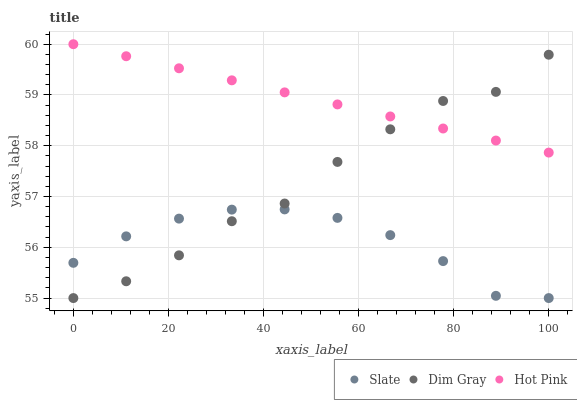Does Slate have the minimum area under the curve?
Answer yes or no. Yes. Does Hot Pink have the maximum area under the curve?
Answer yes or no. Yes. Does Dim Gray have the minimum area under the curve?
Answer yes or no. No. Does Dim Gray have the maximum area under the curve?
Answer yes or no. No. Is Hot Pink the smoothest?
Answer yes or no. Yes. Is Dim Gray the roughest?
Answer yes or no. Yes. Is Dim Gray the smoothest?
Answer yes or no. No. Is Hot Pink the roughest?
Answer yes or no. No. Does Slate have the lowest value?
Answer yes or no. Yes. Does Hot Pink have the lowest value?
Answer yes or no. No. Does Hot Pink have the highest value?
Answer yes or no. Yes. Does Dim Gray have the highest value?
Answer yes or no. No. Is Slate less than Hot Pink?
Answer yes or no. Yes. Is Hot Pink greater than Slate?
Answer yes or no. Yes. Does Dim Gray intersect Slate?
Answer yes or no. Yes. Is Dim Gray less than Slate?
Answer yes or no. No. Is Dim Gray greater than Slate?
Answer yes or no. No. Does Slate intersect Hot Pink?
Answer yes or no. No. 